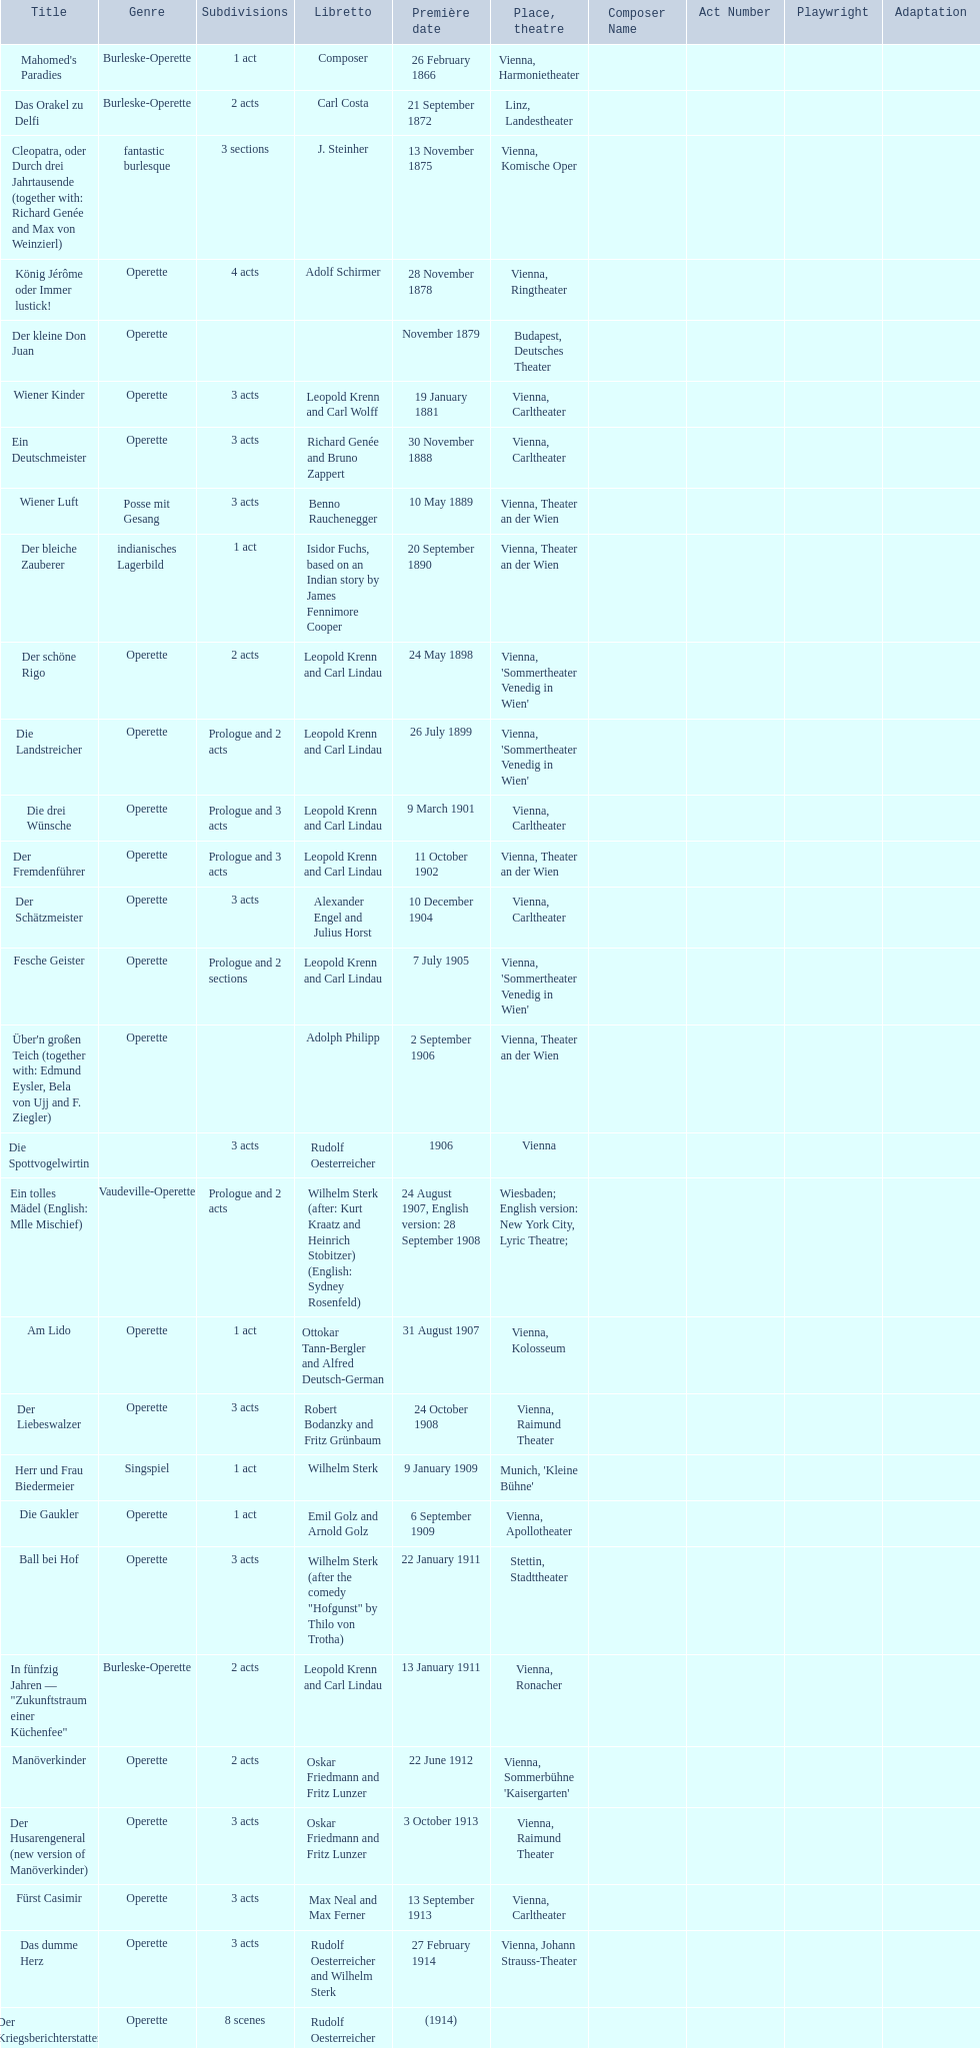In what year was his final operetta released? 1930. 